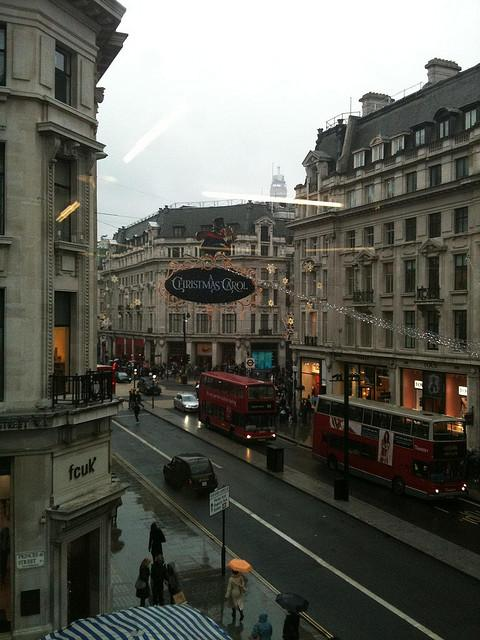Why is the woman carrying an orange umbrella?

Choices:
A) it's raining
B) showing off
C) it's sunny
D) for fashion it's raining 